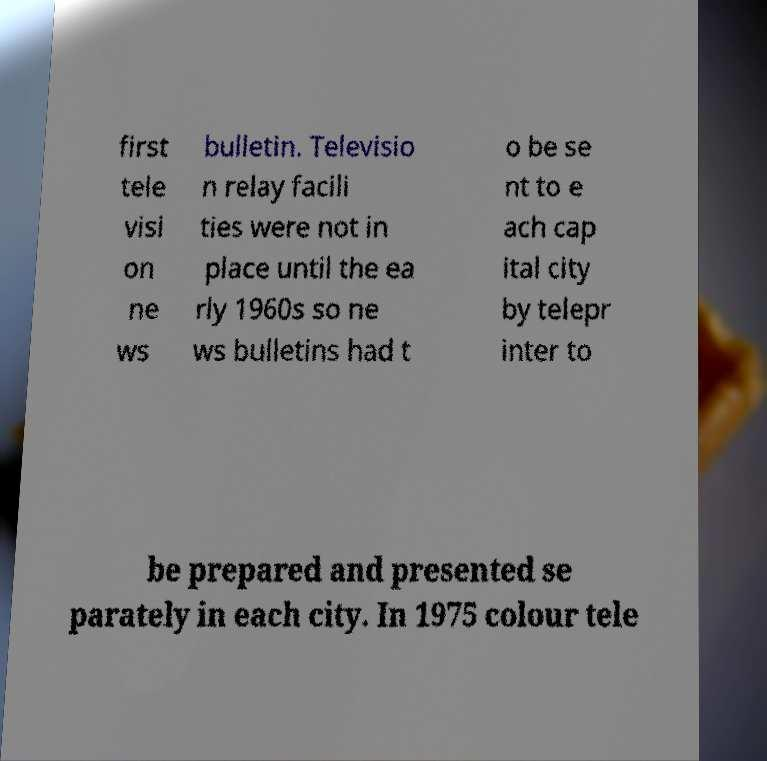There's text embedded in this image that I need extracted. Can you transcribe it verbatim? first tele visi on ne ws bulletin. Televisio n relay facili ties were not in place until the ea rly 1960s so ne ws bulletins had t o be se nt to e ach cap ital city by telepr inter to be prepared and presented se parately in each city. In 1975 colour tele 